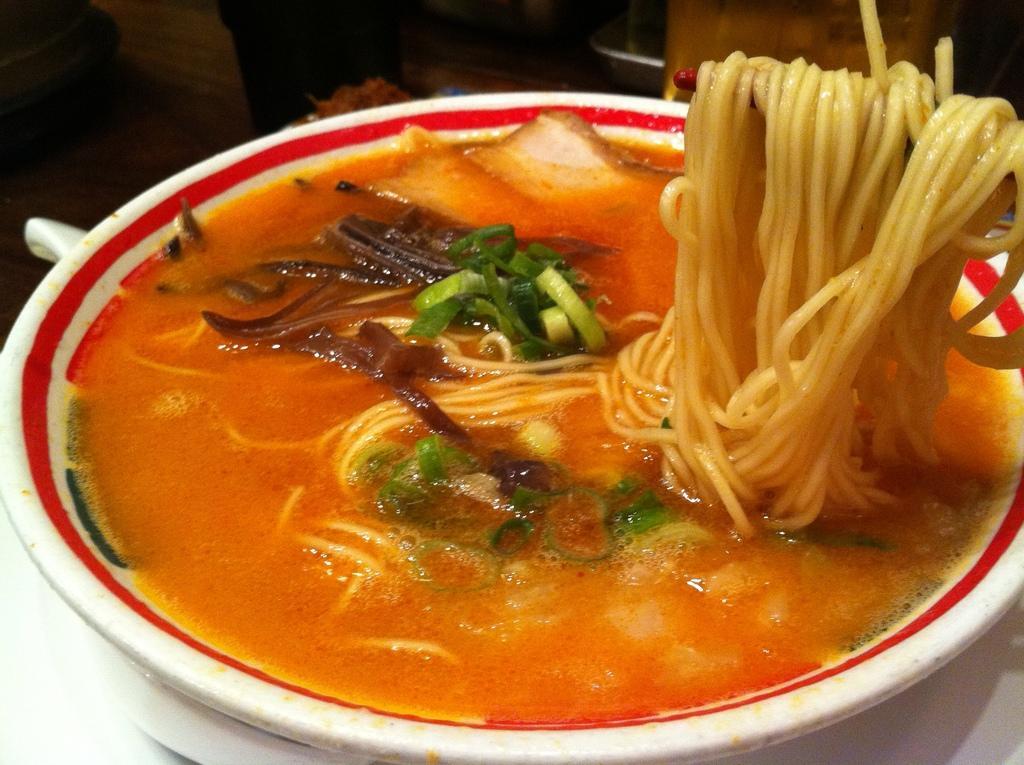Could you give a brief overview of what you see in this image? In this image there is a bowl on the table. There is soup in the bowl. In the soup there are spring onions, bread pieces, onions and spaghetti. To the right there is spaghetti on the chopsticks. 